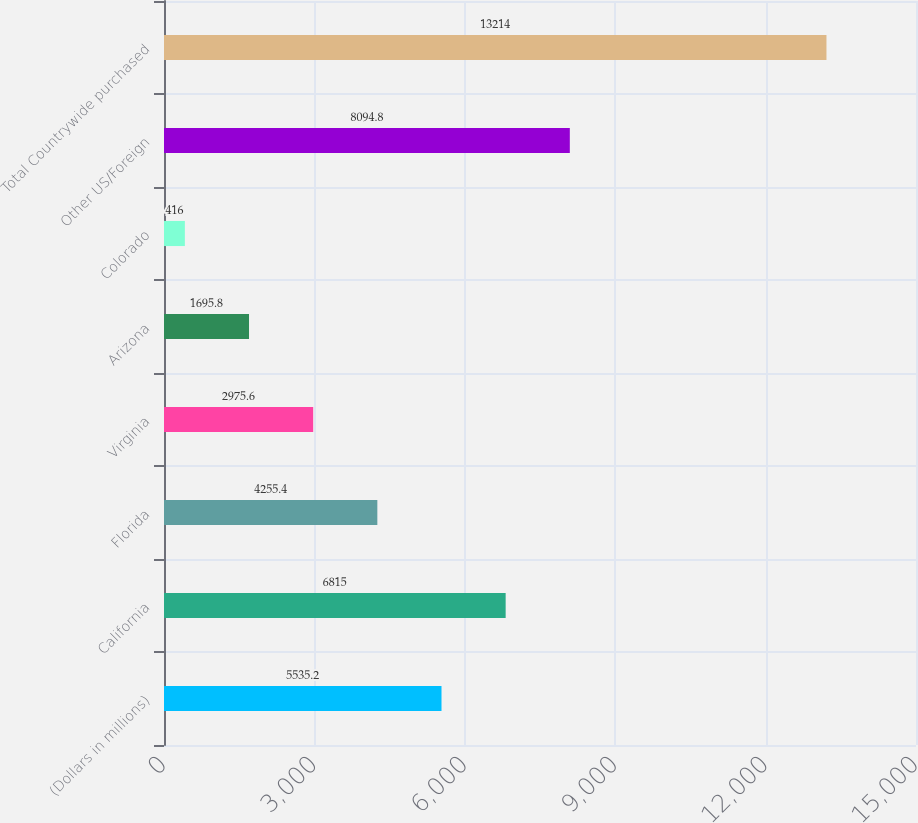Convert chart. <chart><loc_0><loc_0><loc_500><loc_500><bar_chart><fcel>(Dollars in millions)<fcel>California<fcel>Florida<fcel>Virginia<fcel>Arizona<fcel>Colorado<fcel>Other US/Foreign<fcel>Total Countrywide purchased<nl><fcel>5535.2<fcel>6815<fcel>4255.4<fcel>2975.6<fcel>1695.8<fcel>416<fcel>8094.8<fcel>13214<nl></chart> 